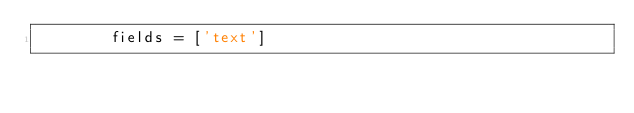Convert code to text. <code><loc_0><loc_0><loc_500><loc_500><_Python_>        fields = ['text']
</code> 